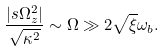<formula> <loc_0><loc_0><loc_500><loc_500>\frac { | s \Omega _ { z } ^ { 2 } | } { \sqrt { \kappa ^ { 2 } } } \sim \Omega \gg 2 \sqrt { \xi } \omega _ { b } .</formula> 